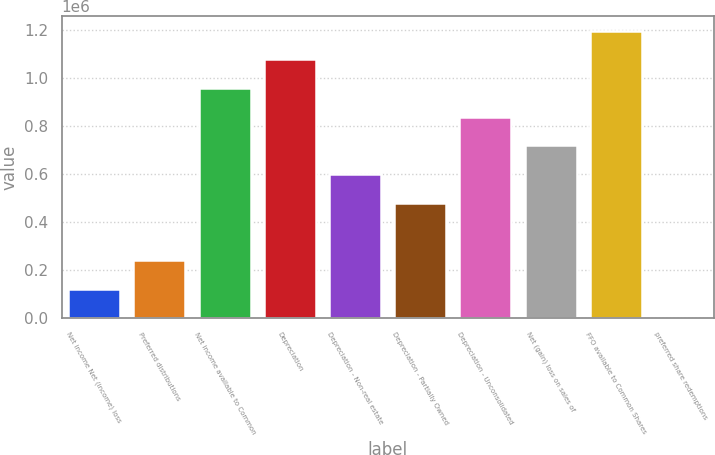Convert chart to OTSL. <chart><loc_0><loc_0><loc_500><loc_500><bar_chart><fcel>Net income Net (income) loss<fcel>Preferred distributions<fcel>Net income available to Common<fcel>Depreciation<fcel>Depreciation - Non-real estate<fcel>Depreciation - Partially Owned<fcel>Depreciation - Unconsolidated<fcel>Net (gain) loss on sales of<fcel>FFO available to Common Shares<fcel>preferred share redemptions<nl><fcel>120644<fcel>240177<fcel>957379<fcel>1.07691e+06<fcel>598778<fcel>479244<fcel>837845<fcel>718312<fcel>1.19645e+06<fcel>1110<nl></chart> 